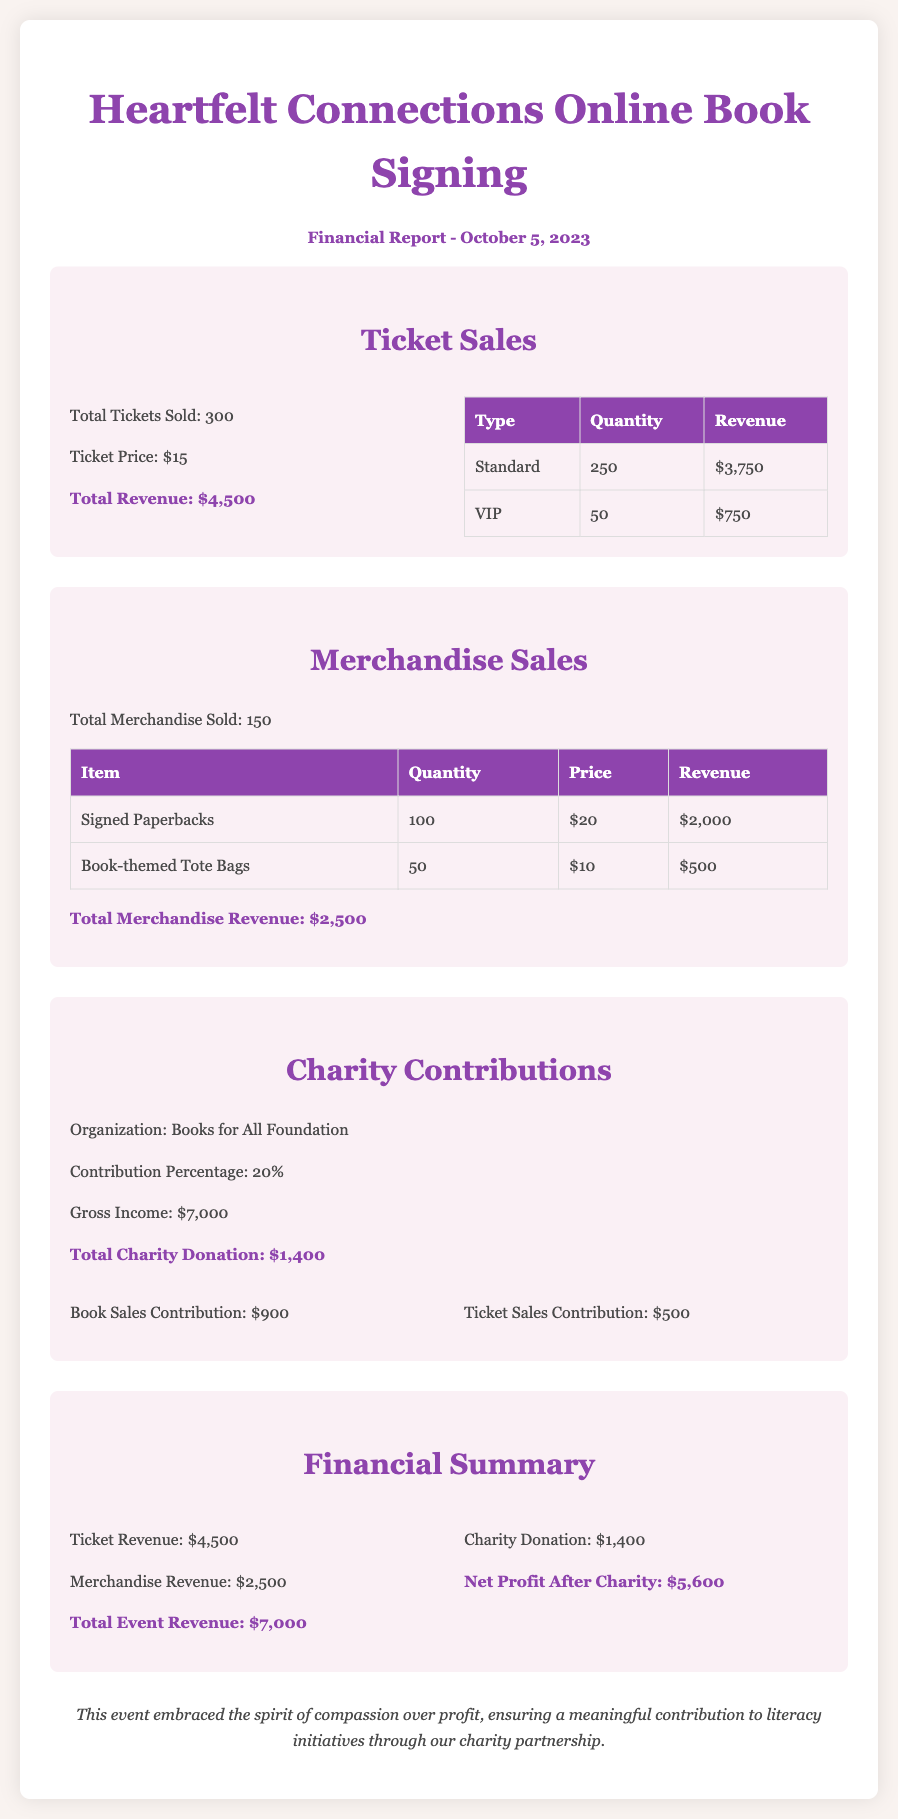what is the total number of tickets sold? The total number of tickets sold is stated directly in the document.
Answer: 300 what is the ticket price? The ticket price is explicitly mentioned in the financial report.
Answer: $15 how much revenue was generated from merchandise sales? The total revenue from merchandise sales is provided in the merchandise section of the document.
Answer: $2,500 who is the charity organization receiving contributions? The charity organization is named clearly in the charity contributions section.
Answer: Books for All Foundation what is the percentage of gross income contributed to charity? The contribution percentage is stated in the charity contributions section of the report.
Answer: 20% what was the total gross income from the event? The total gross income is given in the charity contributions section of the document.
Answer: $7,000 what is the net profit after charity donations? The net profit is calculated in the financial summary section of the report.
Answer: $5,600 how much did ticket sales contribute to charity? The ticket sales contribution to charity is provided in the charity contributions section.
Answer: $500 what is the total charity donation amount? The total charity donation is highlighted in the charity contributions section of the document.
Answer: $1,400 